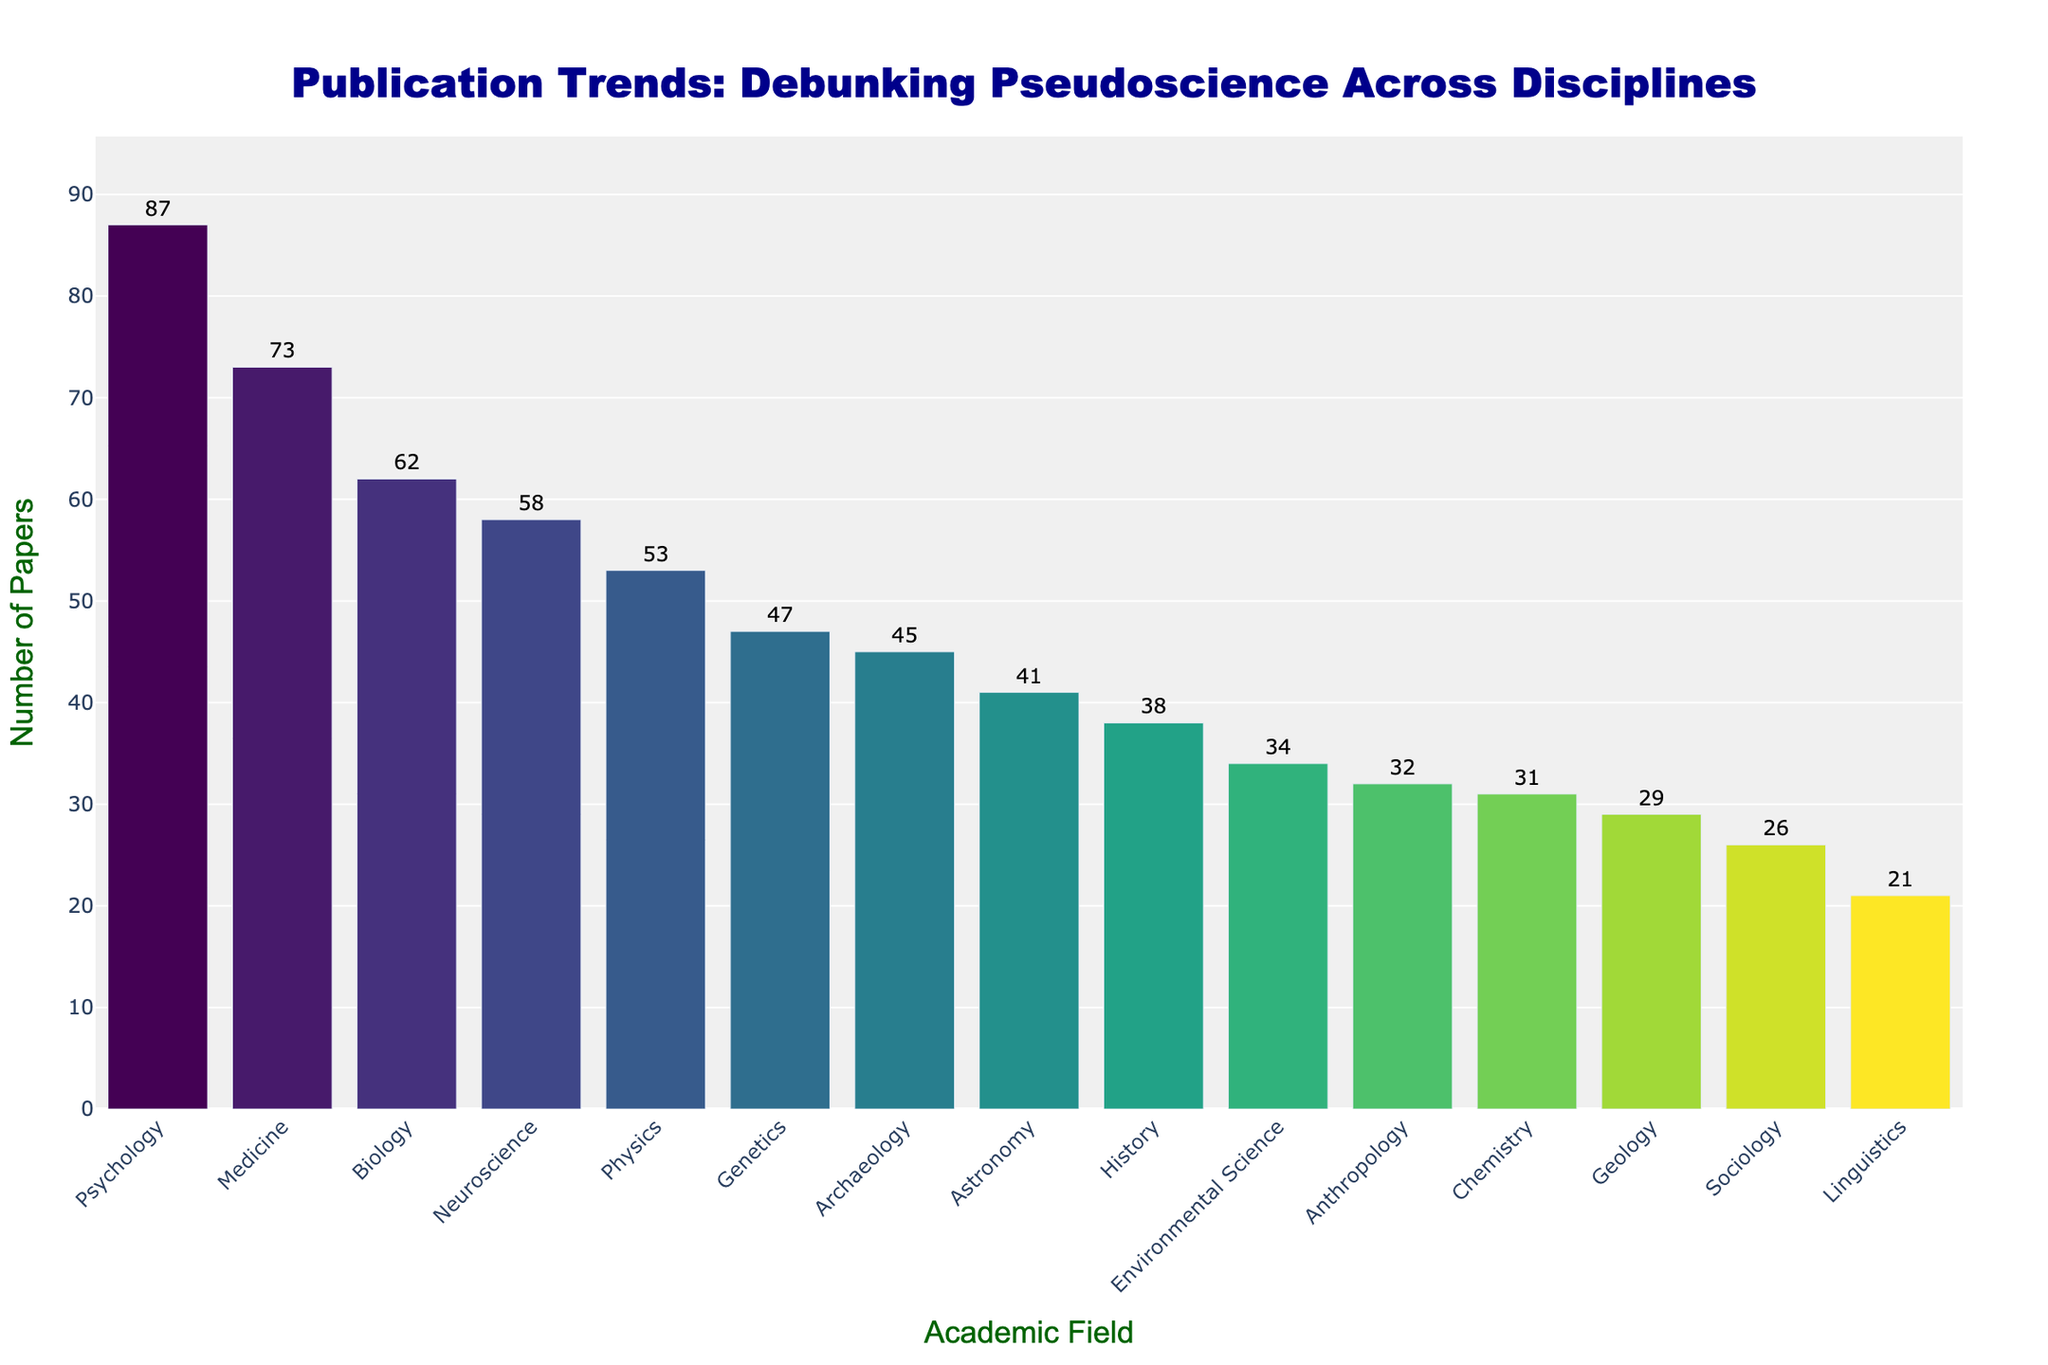Which field has the highest number of papers debunking pseudoscientific claims? The tallest bar indicates the field with the most papers. The highest number of papers is for the field of Psychology.
Answer: Psychology Which field has the lowest number of papers debunking pseudoscientific claims? The shortest bar represents the field with the fewest papers. The lowest number of papers is in Linguistics.
Answer: Linguistics By how much does the number of papers in Psychology exceed those in History? Locate the bars for Psychology and History, and subtract the value for History from Psychology (87 - 38). The excess is 49 papers.
Answer: 49 What is the difference in the number of papers between Medicine and Anthropology? Find the bars for Medicine and Anthropology, then subtract the quantity for Anthropology from Medicine (73 - 32). The difference is 41 papers.
Answer: 41 Which field has more papers: Neuroscience or Astronomy, and by how many? Compare the heights and values of the bars for Neuroscience and Astronomy. Neuroscience has 58 papers, while Astronomy has 41. The difference is 17 papers.
Answer: Neuroscience, 17 What is the average number of papers published in Environmental Science, Sociology, and Chemistry? Add the values for Environmental Science, Sociology, and Chemistry (34 + 26 + 31) and then divide by 3. The average is 30.33 papers.
Answer: 30.33 By summing up the publications in History and Archaeology together, do they surpass the publications in Medicine? Sum the values for History and Archaeology (38 + 45 = 83) and compare to Medicine (73). The sum is greater than Medicine’s publication count.
Answer: Yes What is the median value of the number of papers across all fields? First, list the values in ascending order: 21, 26, 29, 31, 32, 34, 38, 41, 45, 47, 53, 58, 62, 73, 87. There are 15 numbers, so the median is the 8th value in this sequence, which is 41.
Answer: 41 How does the publication count in Genetics compare to the total publications in Physics, Geology, and Sociology combined? Add the values for Physics, Geology, and Sociology (53 + 29 + 26 = 108) and compare to Genetics (47). The total combined publications are more.
Answer: Combined total is higher 